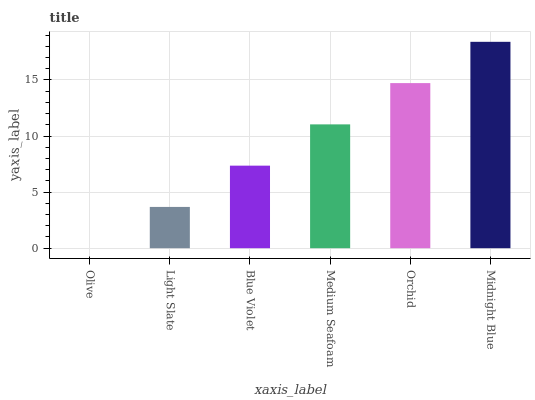Is Olive the minimum?
Answer yes or no. Yes. Is Midnight Blue the maximum?
Answer yes or no. Yes. Is Light Slate the minimum?
Answer yes or no. No. Is Light Slate the maximum?
Answer yes or no. No. Is Light Slate greater than Olive?
Answer yes or no. Yes. Is Olive less than Light Slate?
Answer yes or no. Yes. Is Olive greater than Light Slate?
Answer yes or no. No. Is Light Slate less than Olive?
Answer yes or no. No. Is Medium Seafoam the high median?
Answer yes or no. Yes. Is Blue Violet the low median?
Answer yes or no. Yes. Is Midnight Blue the high median?
Answer yes or no. No. Is Olive the low median?
Answer yes or no. No. 